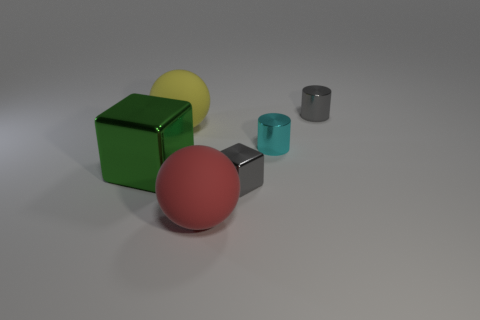Add 2 red matte balls. How many objects exist? 8 Subtract all blocks. How many objects are left? 4 Subtract all yellow cubes. How many red spheres are left? 1 Subtract all gray metal blocks. Subtract all tiny shiny cubes. How many objects are left? 4 Add 2 cyan shiny objects. How many cyan shiny objects are left? 3 Add 4 tiny cylinders. How many tiny cylinders exist? 6 Subtract 0 green cylinders. How many objects are left? 6 Subtract 2 blocks. How many blocks are left? 0 Subtract all cyan cubes. Subtract all red cylinders. How many cubes are left? 2 